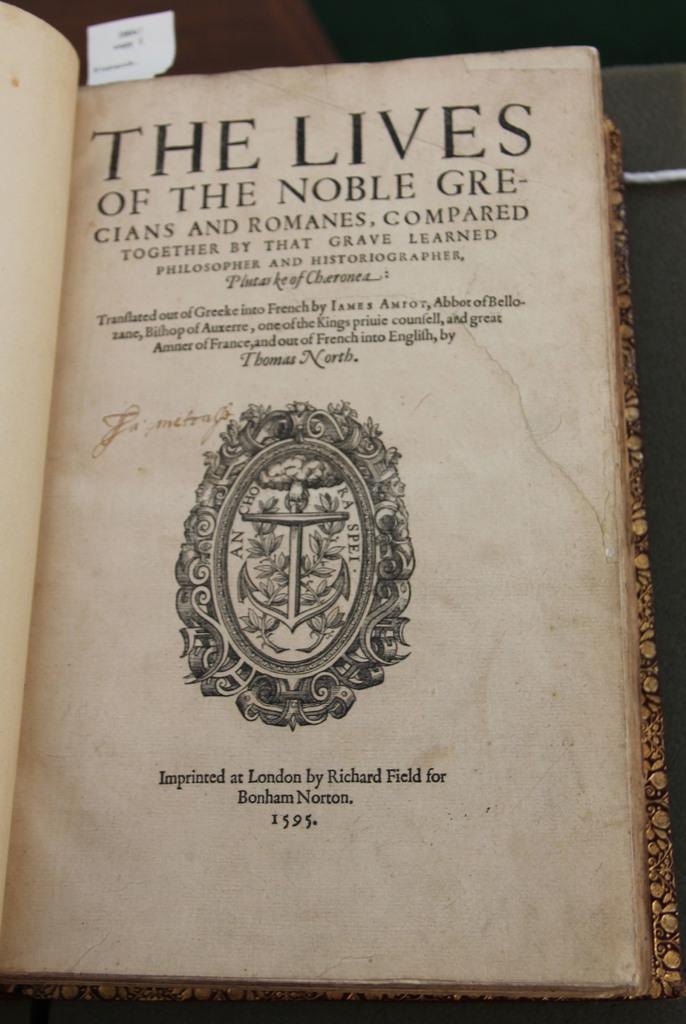<image>
Offer a succinct explanation of the picture presented. The title page of The Lives of the Noble Grecians and Romanes shows a fancy crest with an anchor on it. 